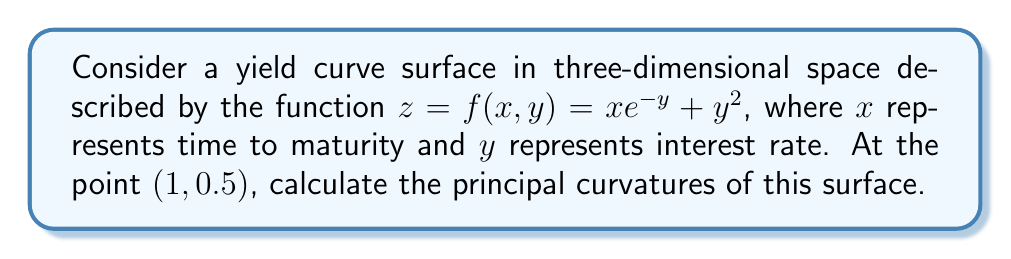Could you help me with this problem? To find the principal curvatures, we need to follow these steps:

1) First, calculate the first and second partial derivatives:
   $f_x = e^{-y}$
   $f_y = -xe^{-y} + 2y$
   $f_{xx} = 0$
   $f_{yy} = xe^{-y} + 2$
   $f_{xy} = f_{yx} = -e^{-y}$

2) At the point $(1, 0.5)$, evaluate these derivatives:
   $f_x = e^{-0.5}$
   $f_y = -e^{-0.5} + 1$
   $f_{xx} = 0$
   $f_{yy} = e^{-0.5} + 2$
   $f_{xy} = -e^{-0.5}$

3) Calculate the coefficients of the first fundamental form:
   $E = 1 + (f_x)^2 = 1 + e^{-1}$
   $F = f_x f_y = e^{-0.5}(-e^{-0.5} + 1)$
   $G = 1 + (f_y)^2 = 1 + (-e^{-0.5} + 1)^2$

4) Calculate the coefficients of the second fundamental form:
   $L = \frac{f_{xx}}{\sqrt{1 + (f_x)^2 + (f_y)^2}} = 0$
   $M = \frac{f_{xy}}{\sqrt{1 + (f_x)^2 + (f_y)^2}} = \frac{-e^{-0.5}}{\sqrt{1 + e^{-1} + (-e^{-0.5} + 1)^2}}$
   $N = \frac{f_{yy}}{\sqrt{1 + (f_x)^2 + (f_y)^2}} = \frac{e^{-0.5} + 2}{\sqrt{1 + e^{-1} + (-e^{-0.5} + 1)^2}}$

5) The principal curvatures are the eigenvalues of the shape operator, which can be found by solving:
   $\det(S - \kappa I) = 0$, where $S = \begin{bmatrix} \frac{L}{E} & \frac{M}{E} \\ \frac{M}{G} & \frac{N}{G} \end{bmatrix}$

6) This leads to the quadratic equation:
   $\kappa^2 - ({\frac{L}{E} + \frac{N}{G}})\kappa + \frac{LN-M^2}{EG} = 0$

7) The solutions to this equation are the principal curvatures:
   $\kappa_1, \kappa_2 = \frac{{\frac{L}{E} + \frac{N}{G}} \pm \sqrt{({\frac{L}{E} + \frac{N}{G}})^2 - 4\frac{LN-M^2}{EG}}}{2}$

8) Substituting the values we calculated earlier gives us the final result.
Answer: $\kappa_1 = \frac{N}{G}, \kappa_2 = 0$ 